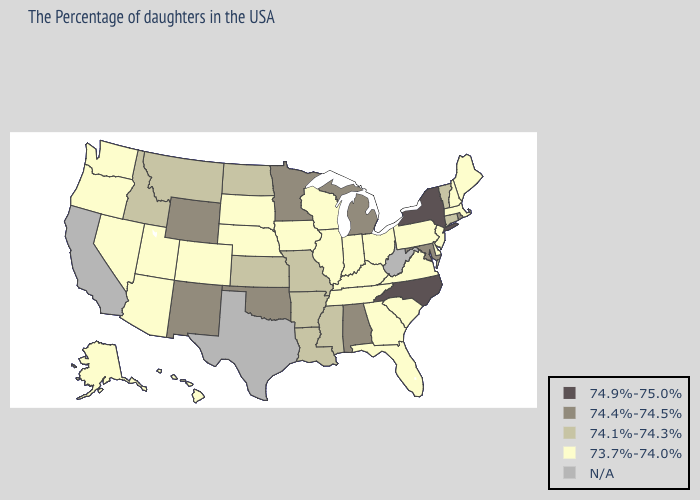Does Michigan have the lowest value in the MidWest?
Short answer required. No. Name the states that have a value in the range 74.4%-74.5%?
Be succinct. Rhode Island, Maryland, Michigan, Alabama, Minnesota, Oklahoma, Wyoming, New Mexico. Does the first symbol in the legend represent the smallest category?
Answer briefly. No. What is the value of Oklahoma?
Answer briefly. 74.4%-74.5%. What is the lowest value in states that border Oklahoma?
Give a very brief answer. 73.7%-74.0%. What is the lowest value in the South?
Write a very short answer. 73.7%-74.0%. Does Oklahoma have the lowest value in the USA?
Short answer required. No. Name the states that have a value in the range 73.7%-74.0%?
Give a very brief answer. Maine, Massachusetts, New Hampshire, New Jersey, Delaware, Pennsylvania, Virginia, South Carolina, Ohio, Florida, Georgia, Kentucky, Indiana, Tennessee, Wisconsin, Illinois, Iowa, Nebraska, South Dakota, Colorado, Utah, Arizona, Nevada, Washington, Oregon, Alaska, Hawaii. What is the highest value in the South ?
Keep it brief. 74.9%-75.0%. Name the states that have a value in the range 74.9%-75.0%?
Write a very short answer. New York, North Carolina. 